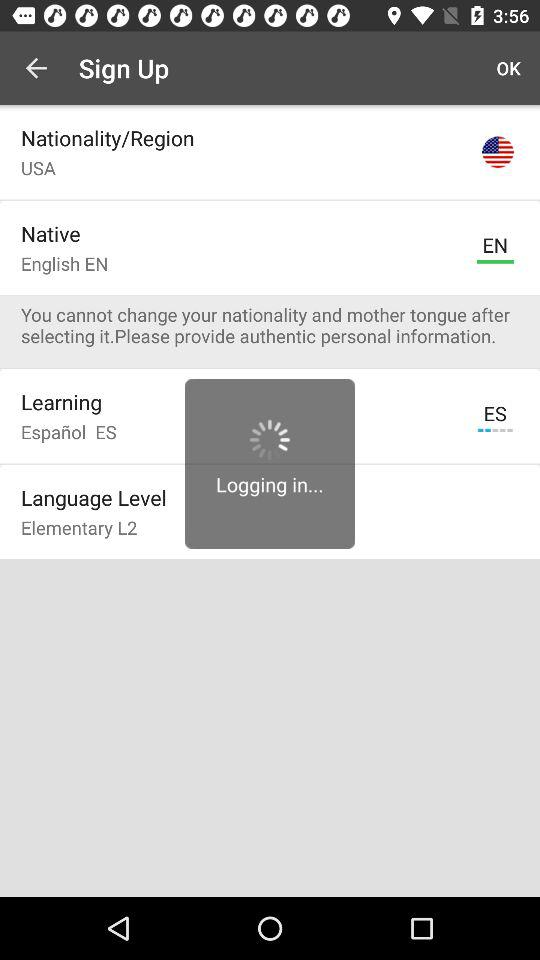What is the user name to continue on the login page? The user name to continue on the login page is Laura. 